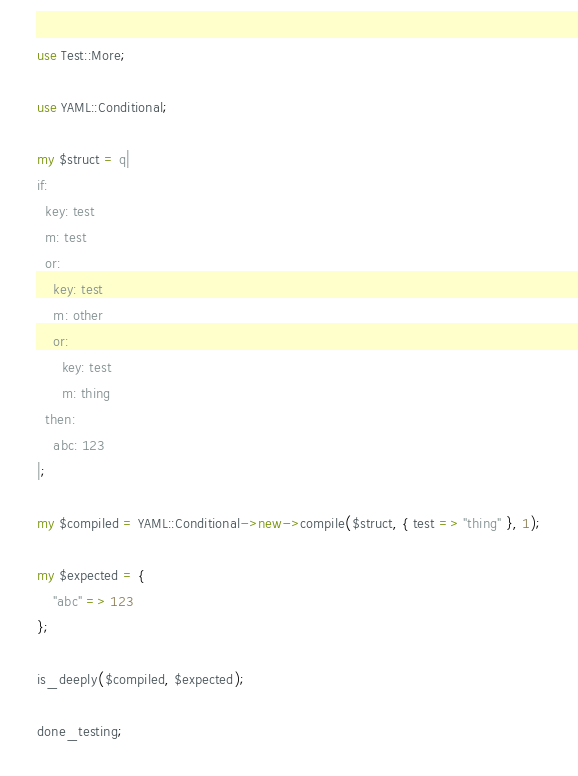<code> <loc_0><loc_0><loc_500><loc_500><_Perl_>use Test::More;

use YAML::Conditional;

my $struct = q|
if:
  key: test
  m: test
  or:
    key: test
    m: other
    or:
      key: test
      m: thing
  then:
    abc: 123
|;

my $compiled = YAML::Conditional->new->compile($struct, { test => "thing" }, 1);

my $expected = {
	"abc" => 123
};

is_deeply($compiled, $expected);

done_testing;
</code> 